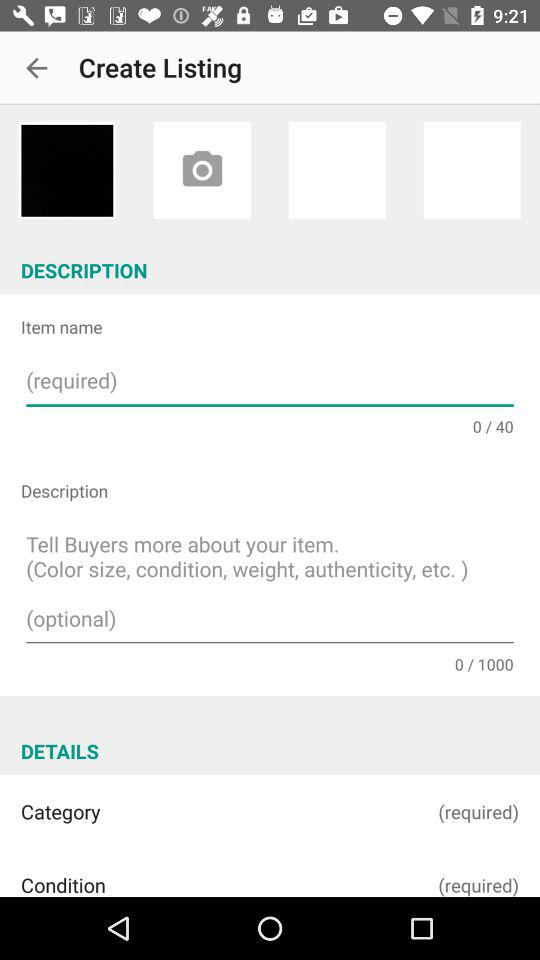What is the maximum character length allowed for an item description? The maximum character length allowed for an item description is 1000. 